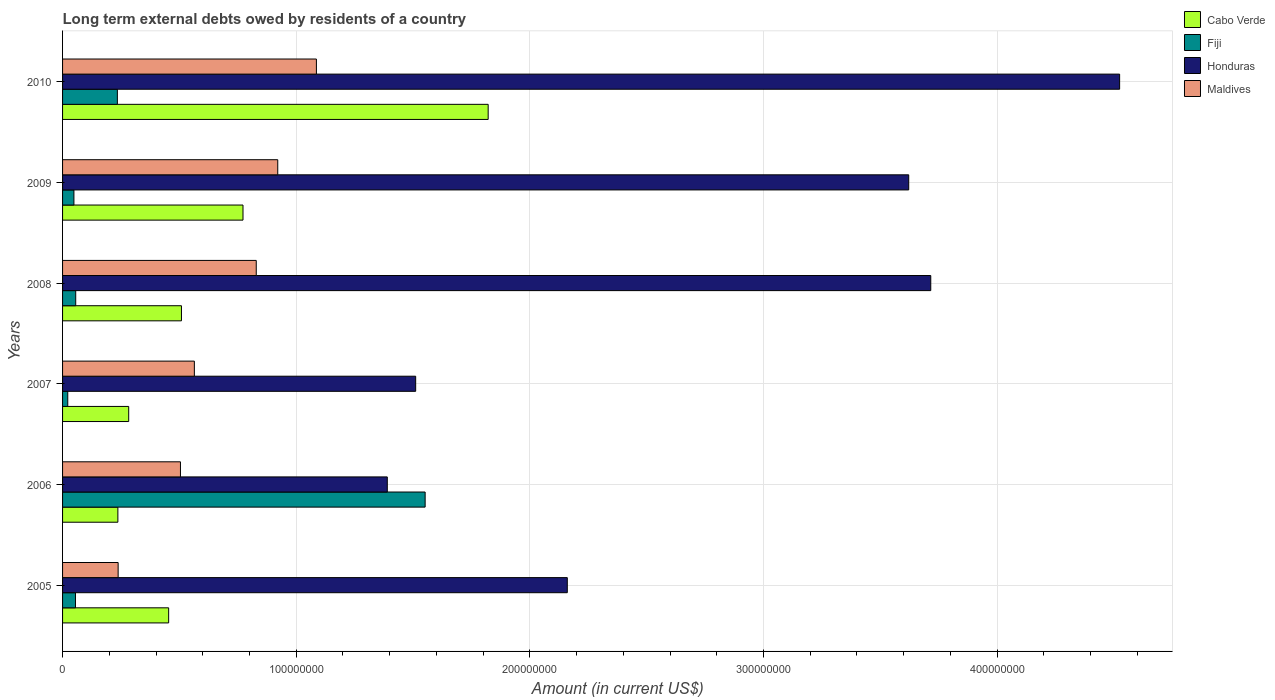How many different coloured bars are there?
Your answer should be compact. 4. Are the number of bars per tick equal to the number of legend labels?
Your answer should be compact. Yes. How many bars are there on the 4th tick from the bottom?
Your answer should be compact. 4. What is the amount of long-term external debts owed by residents in Maldives in 2010?
Provide a succinct answer. 1.09e+08. Across all years, what is the maximum amount of long-term external debts owed by residents in Cabo Verde?
Your response must be concise. 1.82e+08. Across all years, what is the minimum amount of long-term external debts owed by residents in Honduras?
Provide a succinct answer. 1.39e+08. In which year was the amount of long-term external debts owed by residents in Honduras minimum?
Give a very brief answer. 2006. What is the total amount of long-term external debts owed by residents in Fiji in the graph?
Make the answer very short. 1.97e+08. What is the difference between the amount of long-term external debts owed by residents in Honduras in 2006 and that in 2010?
Give a very brief answer. -3.13e+08. What is the difference between the amount of long-term external debts owed by residents in Honduras in 2006 and the amount of long-term external debts owed by residents in Cabo Verde in 2009?
Your answer should be very brief. 6.18e+07. What is the average amount of long-term external debts owed by residents in Fiji per year?
Offer a terse response. 3.28e+07. In the year 2008, what is the difference between the amount of long-term external debts owed by residents in Honduras and amount of long-term external debts owed by residents in Cabo Verde?
Give a very brief answer. 3.21e+08. What is the ratio of the amount of long-term external debts owed by residents in Cabo Verde in 2005 to that in 2007?
Offer a very short reply. 1.6. Is the amount of long-term external debts owed by residents in Fiji in 2008 less than that in 2009?
Make the answer very short. No. What is the difference between the highest and the second highest amount of long-term external debts owed by residents in Cabo Verde?
Ensure brevity in your answer.  1.05e+08. What is the difference between the highest and the lowest amount of long-term external debts owed by residents in Maldives?
Offer a terse response. 8.49e+07. In how many years, is the amount of long-term external debts owed by residents in Fiji greater than the average amount of long-term external debts owed by residents in Fiji taken over all years?
Ensure brevity in your answer.  1. Is it the case that in every year, the sum of the amount of long-term external debts owed by residents in Cabo Verde and amount of long-term external debts owed by residents in Maldives is greater than the sum of amount of long-term external debts owed by residents in Fiji and amount of long-term external debts owed by residents in Honduras?
Your answer should be compact. No. What does the 2nd bar from the top in 2010 represents?
Your response must be concise. Honduras. What does the 2nd bar from the bottom in 2009 represents?
Provide a succinct answer. Fiji. How many bars are there?
Your answer should be very brief. 24. Are all the bars in the graph horizontal?
Your answer should be very brief. Yes. Are the values on the major ticks of X-axis written in scientific E-notation?
Keep it short and to the point. No. Does the graph contain any zero values?
Make the answer very short. No. Where does the legend appear in the graph?
Your answer should be very brief. Top right. How are the legend labels stacked?
Your answer should be compact. Vertical. What is the title of the graph?
Make the answer very short. Long term external debts owed by residents of a country. What is the label or title of the X-axis?
Your response must be concise. Amount (in current US$). What is the label or title of the Y-axis?
Your answer should be very brief. Years. What is the Amount (in current US$) of Cabo Verde in 2005?
Keep it short and to the point. 4.54e+07. What is the Amount (in current US$) in Fiji in 2005?
Offer a terse response. 5.53e+06. What is the Amount (in current US$) of Honduras in 2005?
Give a very brief answer. 2.16e+08. What is the Amount (in current US$) in Maldives in 2005?
Provide a short and direct response. 2.38e+07. What is the Amount (in current US$) in Cabo Verde in 2006?
Give a very brief answer. 2.37e+07. What is the Amount (in current US$) of Fiji in 2006?
Your answer should be very brief. 1.55e+08. What is the Amount (in current US$) in Honduras in 2006?
Ensure brevity in your answer.  1.39e+08. What is the Amount (in current US$) of Maldives in 2006?
Your response must be concise. 5.05e+07. What is the Amount (in current US$) of Cabo Verde in 2007?
Your answer should be very brief. 2.83e+07. What is the Amount (in current US$) of Fiji in 2007?
Your response must be concise. 2.23e+06. What is the Amount (in current US$) of Honduras in 2007?
Your answer should be very brief. 1.51e+08. What is the Amount (in current US$) in Maldives in 2007?
Ensure brevity in your answer.  5.64e+07. What is the Amount (in current US$) in Cabo Verde in 2008?
Ensure brevity in your answer.  5.09e+07. What is the Amount (in current US$) of Fiji in 2008?
Keep it short and to the point. 5.63e+06. What is the Amount (in current US$) in Honduras in 2008?
Your response must be concise. 3.72e+08. What is the Amount (in current US$) of Maldives in 2008?
Ensure brevity in your answer.  8.29e+07. What is the Amount (in current US$) of Cabo Verde in 2009?
Offer a very short reply. 7.72e+07. What is the Amount (in current US$) of Fiji in 2009?
Keep it short and to the point. 4.86e+06. What is the Amount (in current US$) in Honduras in 2009?
Keep it short and to the point. 3.62e+08. What is the Amount (in current US$) of Maldives in 2009?
Your answer should be very brief. 9.21e+07. What is the Amount (in current US$) in Cabo Verde in 2010?
Offer a very short reply. 1.82e+08. What is the Amount (in current US$) of Fiji in 2010?
Your answer should be compact. 2.35e+07. What is the Amount (in current US$) of Honduras in 2010?
Offer a terse response. 4.52e+08. What is the Amount (in current US$) of Maldives in 2010?
Provide a succinct answer. 1.09e+08. Across all years, what is the maximum Amount (in current US$) in Cabo Verde?
Provide a succinct answer. 1.82e+08. Across all years, what is the maximum Amount (in current US$) of Fiji?
Provide a succinct answer. 1.55e+08. Across all years, what is the maximum Amount (in current US$) in Honduras?
Make the answer very short. 4.52e+08. Across all years, what is the maximum Amount (in current US$) in Maldives?
Offer a very short reply. 1.09e+08. Across all years, what is the minimum Amount (in current US$) in Cabo Verde?
Your answer should be very brief. 2.37e+07. Across all years, what is the minimum Amount (in current US$) in Fiji?
Your answer should be compact. 2.23e+06. Across all years, what is the minimum Amount (in current US$) in Honduras?
Provide a short and direct response. 1.39e+08. Across all years, what is the minimum Amount (in current US$) in Maldives?
Your answer should be very brief. 2.38e+07. What is the total Amount (in current US$) of Cabo Verde in the graph?
Your answer should be compact. 4.08e+08. What is the total Amount (in current US$) of Fiji in the graph?
Provide a short and direct response. 1.97e+08. What is the total Amount (in current US$) in Honduras in the graph?
Provide a short and direct response. 1.69e+09. What is the total Amount (in current US$) in Maldives in the graph?
Provide a short and direct response. 4.14e+08. What is the difference between the Amount (in current US$) in Cabo Verde in 2005 and that in 2006?
Provide a short and direct response. 2.17e+07. What is the difference between the Amount (in current US$) in Fiji in 2005 and that in 2006?
Ensure brevity in your answer.  -1.50e+08. What is the difference between the Amount (in current US$) in Honduras in 2005 and that in 2006?
Offer a very short reply. 7.70e+07. What is the difference between the Amount (in current US$) of Maldives in 2005 and that in 2006?
Provide a succinct answer. -2.67e+07. What is the difference between the Amount (in current US$) in Cabo Verde in 2005 and that in 2007?
Keep it short and to the point. 1.71e+07. What is the difference between the Amount (in current US$) of Fiji in 2005 and that in 2007?
Your response must be concise. 3.30e+06. What is the difference between the Amount (in current US$) in Honduras in 2005 and that in 2007?
Give a very brief answer. 6.49e+07. What is the difference between the Amount (in current US$) in Maldives in 2005 and that in 2007?
Keep it short and to the point. -3.26e+07. What is the difference between the Amount (in current US$) in Cabo Verde in 2005 and that in 2008?
Keep it short and to the point. -5.48e+06. What is the difference between the Amount (in current US$) in Fiji in 2005 and that in 2008?
Ensure brevity in your answer.  -1.01e+05. What is the difference between the Amount (in current US$) of Honduras in 2005 and that in 2008?
Provide a succinct answer. -1.56e+08. What is the difference between the Amount (in current US$) in Maldives in 2005 and that in 2008?
Offer a terse response. -5.91e+07. What is the difference between the Amount (in current US$) of Cabo Verde in 2005 and that in 2009?
Make the answer very short. -3.18e+07. What is the difference between the Amount (in current US$) of Fiji in 2005 and that in 2009?
Make the answer very short. 6.65e+05. What is the difference between the Amount (in current US$) in Honduras in 2005 and that in 2009?
Your answer should be compact. -1.46e+08. What is the difference between the Amount (in current US$) of Maldives in 2005 and that in 2009?
Offer a terse response. -6.83e+07. What is the difference between the Amount (in current US$) of Cabo Verde in 2005 and that in 2010?
Offer a very short reply. -1.37e+08. What is the difference between the Amount (in current US$) in Fiji in 2005 and that in 2010?
Offer a very short reply. -1.79e+07. What is the difference between the Amount (in current US$) of Honduras in 2005 and that in 2010?
Give a very brief answer. -2.36e+08. What is the difference between the Amount (in current US$) in Maldives in 2005 and that in 2010?
Offer a very short reply. -8.49e+07. What is the difference between the Amount (in current US$) of Cabo Verde in 2006 and that in 2007?
Your response must be concise. -4.64e+06. What is the difference between the Amount (in current US$) of Fiji in 2006 and that in 2007?
Your response must be concise. 1.53e+08. What is the difference between the Amount (in current US$) in Honduras in 2006 and that in 2007?
Provide a short and direct response. -1.21e+07. What is the difference between the Amount (in current US$) of Maldives in 2006 and that in 2007?
Make the answer very short. -5.95e+06. What is the difference between the Amount (in current US$) of Cabo Verde in 2006 and that in 2008?
Your answer should be compact. -2.72e+07. What is the difference between the Amount (in current US$) in Fiji in 2006 and that in 2008?
Your answer should be very brief. 1.50e+08. What is the difference between the Amount (in current US$) of Honduras in 2006 and that in 2008?
Your response must be concise. -2.33e+08. What is the difference between the Amount (in current US$) in Maldives in 2006 and that in 2008?
Keep it short and to the point. -3.24e+07. What is the difference between the Amount (in current US$) of Cabo Verde in 2006 and that in 2009?
Your answer should be very brief. -5.36e+07. What is the difference between the Amount (in current US$) of Fiji in 2006 and that in 2009?
Your response must be concise. 1.50e+08. What is the difference between the Amount (in current US$) of Honduras in 2006 and that in 2009?
Offer a very short reply. -2.23e+08. What is the difference between the Amount (in current US$) of Maldives in 2006 and that in 2009?
Your response must be concise. -4.16e+07. What is the difference between the Amount (in current US$) of Cabo Verde in 2006 and that in 2010?
Your response must be concise. -1.58e+08. What is the difference between the Amount (in current US$) of Fiji in 2006 and that in 2010?
Your answer should be compact. 1.32e+08. What is the difference between the Amount (in current US$) of Honduras in 2006 and that in 2010?
Make the answer very short. -3.13e+08. What is the difference between the Amount (in current US$) of Maldives in 2006 and that in 2010?
Your answer should be very brief. -5.82e+07. What is the difference between the Amount (in current US$) in Cabo Verde in 2007 and that in 2008?
Your answer should be compact. -2.26e+07. What is the difference between the Amount (in current US$) of Fiji in 2007 and that in 2008?
Offer a terse response. -3.40e+06. What is the difference between the Amount (in current US$) in Honduras in 2007 and that in 2008?
Keep it short and to the point. -2.20e+08. What is the difference between the Amount (in current US$) in Maldives in 2007 and that in 2008?
Make the answer very short. -2.65e+07. What is the difference between the Amount (in current US$) in Cabo Verde in 2007 and that in 2009?
Offer a terse response. -4.89e+07. What is the difference between the Amount (in current US$) in Fiji in 2007 and that in 2009?
Make the answer very short. -2.64e+06. What is the difference between the Amount (in current US$) of Honduras in 2007 and that in 2009?
Ensure brevity in your answer.  -2.11e+08. What is the difference between the Amount (in current US$) of Maldives in 2007 and that in 2009?
Ensure brevity in your answer.  -3.57e+07. What is the difference between the Amount (in current US$) in Cabo Verde in 2007 and that in 2010?
Provide a short and direct response. -1.54e+08. What is the difference between the Amount (in current US$) of Fiji in 2007 and that in 2010?
Offer a terse response. -2.12e+07. What is the difference between the Amount (in current US$) in Honduras in 2007 and that in 2010?
Offer a very short reply. -3.01e+08. What is the difference between the Amount (in current US$) of Maldives in 2007 and that in 2010?
Offer a very short reply. -5.22e+07. What is the difference between the Amount (in current US$) of Cabo Verde in 2008 and that in 2009?
Keep it short and to the point. -2.63e+07. What is the difference between the Amount (in current US$) of Fiji in 2008 and that in 2009?
Give a very brief answer. 7.66e+05. What is the difference between the Amount (in current US$) in Honduras in 2008 and that in 2009?
Your answer should be very brief. 9.44e+06. What is the difference between the Amount (in current US$) in Maldives in 2008 and that in 2009?
Make the answer very short. -9.20e+06. What is the difference between the Amount (in current US$) of Cabo Verde in 2008 and that in 2010?
Provide a short and direct response. -1.31e+08. What is the difference between the Amount (in current US$) of Fiji in 2008 and that in 2010?
Provide a succinct answer. -1.78e+07. What is the difference between the Amount (in current US$) in Honduras in 2008 and that in 2010?
Your answer should be very brief. -8.08e+07. What is the difference between the Amount (in current US$) of Maldives in 2008 and that in 2010?
Your answer should be very brief. -2.57e+07. What is the difference between the Amount (in current US$) in Cabo Verde in 2009 and that in 2010?
Provide a short and direct response. -1.05e+08. What is the difference between the Amount (in current US$) of Fiji in 2009 and that in 2010?
Provide a short and direct response. -1.86e+07. What is the difference between the Amount (in current US$) in Honduras in 2009 and that in 2010?
Provide a short and direct response. -9.03e+07. What is the difference between the Amount (in current US$) in Maldives in 2009 and that in 2010?
Your response must be concise. -1.65e+07. What is the difference between the Amount (in current US$) of Cabo Verde in 2005 and the Amount (in current US$) of Fiji in 2006?
Provide a short and direct response. -1.10e+08. What is the difference between the Amount (in current US$) of Cabo Verde in 2005 and the Amount (in current US$) of Honduras in 2006?
Provide a short and direct response. -9.36e+07. What is the difference between the Amount (in current US$) of Cabo Verde in 2005 and the Amount (in current US$) of Maldives in 2006?
Provide a succinct answer. -5.05e+06. What is the difference between the Amount (in current US$) of Fiji in 2005 and the Amount (in current US$) of Honduras in 2006?
Offer a terse response. -1.33e+08. What is the difference between the Amount (in current US$) in Fiji in 2005 and the Amount (in current US$) in Maldives in 2006?
Keep it short and to the point. -4.49e+07. What is the difference between the Amount (in current US$) in Honduras in 2005 and the Amount (in current US$) in Maldives in 2006?
Your answer should be very brief. 1.66e+08. What is the difference between the Amount (in current US$) of Cabo Verde in 2005 and the Amount (in current US$) of Fiji in 2007?
Your response must be concise. 4.32e+07. What is the difference between the Amount (in current US$) in Cabo Verde in 2005 and the Amount (in current US$) in Honduras in 2007?
Your answer should be compact. -1.06e+08. What is the difference between the Amount (in current US$) in Cabo Verde in 2005 and the Amount (in current US$) in Maldives in 2007?
Ensure brevity in your answer.  -1.10e+07. What is the difference between the Amount (in current US$) of Fiji in 2005 and the Amount (in current US$) of Honduras in 2007?
Ensure brevity in your answer.  -1.46e+08. What is the difference between the Amount (in current US$) in Fiji in 2005 and the Amount (in current US$) in Maldives in 2007?
Your response must be concise. -5.09e+07. What is the difference between the Amount (in current US$) in Honduras in 2005 and the Amount (in current US$) in Maldives in 2007?
Offer a terse response. 1.60e+08. What is the difference between the Amount (in current US$) in Cabo Verde in 2005 and the Amount (in current US$) in Fiji in 2008?
Your response must be concise. 3.98e+07. What is the difference between the Amount (in current US$) in Cabo Verde in 2005 and the Amount (in current US$) in Honduras in 2008?
Make the answer very short. -3.26e+08. What is the difference between the Amount (in current US$) in Cabo Verde in 2005 and the Amount (in current US$) in Maldives in 2008?
Offer a terse response. -3.75e+07. What is the difference between the Amount (in current US$) of Fiji in 2005 and the Amount (in current US$) of Honduras in 2008?
Keep it short and to the point. -3.66e+08. What is the difference between the Amount (in current US$) of Fiji in 2005 and the Amount (in current US$) of Maldives in 2008?
Offer a terse response. -7.74e+07. What is the difference between the Amount (in current US$) of Honduras in 2005 and the Amount (in current US$) of Maldives in 2008?
Provide a short and direct response. 1.33e+08. What is the difference between the Amount (in current US$) of Cabo Verde in 2005 and the Amount (in current US$) of Fiji in 2009?
Your response must be concise. 4.05e+07. What is the difference between the Amount (in current US$) of Cabo Verde in 2005 and the Amount (in current US$) of Honduras in 2009?
Keep it short and to the point. -3.17e+08. What is the difference between the Amount (in current US$) of Cabo Verde in 2005 and the Amount (in current US$) of Maldives in 2009?
Provide a short and direct response. -4.67e+07. What is the difference between the Amount (in current US$) in Fiji in 2005 and the Amount (in current US$) in Honduras in 2009?
Keep it short and to the point. -3.57e+08. What is the difference between the Amount (in current US$) of Fiji in 2005 and the Amount (in current US$) of Maldives in 2009?
Ensure brevity in your answer.  -8.66e+07. What is the difference between the Amount (in current US$) in Honduras in 2005 and the Amount (in current US$) in Maldives in 2009?
Ensure brevity in your answer.  1.24e+08. What is the difference between the Amount (in current US$) of Cabo Verde in 2005 and the Amount (in current US$) of Fiji in 2010?
Your response must be concise. 2.19e+07. What is the difference between the Amount (in current US$) of Cabo Verde in 2005 and the Amount (in current US$) of Honduras in 2010?
Your response must be concise. -4.07e+08. What is the difference between the Amount (in current US$) of Cabo Verde in 2005 and the Amount (in current US$) of Maldives in 2010?
Give a very brief answer. -6.32e+07. What is the difference between the Amount (in current US$) of Fiji in 2005 and the Amount (in current US$) of Honduras in 2010?
Give a very brief answer. -4.47e+08. What is the difference between the Amount (in current US$) in Fiji in 2005 and the Amount (in current US$) in Maldives in 2010?
Offer a very short reply. -1.03e+08. What is the difference between the Amount (in current US$) in Honduras in 2005 and the Amount (in current US$) in Maldives in 2010?
Provide a succinct answer. 1.07e+08. What is the difference between the Amount (in current US$) of Cabo Verde in 2006 and the Amount (in current US$) of Fiji in 2007?
Provide a succinct answer. 2.14e+07. What is the difference between the Amount (in current US$) of Cabo Verde in 2006 and the Amount (in current US$) of Honduras in 2007?
Offer a terse response. -1.27e+08. What is the difference between the Amount (in current US$) in Cabo Verde in 2006 and the Amount (in current US$) in Maldives in 2007?
Ensure brevity in your answer.  -3.27e+07. What is the difference between the Amount (in current US$) in Fiji in 2006 and the Amount (in current US$) in Honduras in 2007?
Offer a terse response. 4.05e+06. What is the difference between the Amount (in current US$) in Fiji in 2006 and the Amount (in current US$) in Maldives in 2007?
Make the answer very short. 9.88e+07. What is the difference between the Amount (in current US$) of Honduras in 2006 and the Amount (in current US$) of Maldives in 2007?
Your answer should be very brief. 8.26e+07. What is the difference between the Amount (in current US$) of Cabo Verde in 2006 and the Amount (in current US$) of Fiji in 2008?
Offer a very short reply. 1.80e+07. What is the difference between the Amount (in current US$) in Cabo Verde in 2006 and the Amount (in current US$) in Honduras in 2008?
Your response must be concise. -3.48e+08. What is the difference between the Amount (in current US$) in Cabo Verde in 2006 and the Amount (in current US$) in Maldives in 2008?
Ensure brevity in your answer.  -5.92e+07. What is the difference between the Amount (in current US$) in Fiji in 2006 and the Amount (in current US$) in Honduras in 2008?
Your answer should be very brief. -2.16e+08. What is the difference between the Amount (in current US$) in Fiji in 2006 and the Amount (in current US$) in Maldives in 2008?
Your response must be concise. 7.23e+07. What is the difference between the Amount (in current US$) of Honduras in 2006 and the Amount (in current US$) of Maldives in 2008?
Your response must be concise. 5.61e+07. What is the difference between the Amount (in current US$) in Cabo Verde in 2006 and the Amount (in current US$) in Fiji in 2009?
Offer a terse response. 1.88e+07. What is the difference between the Amount (in current US$) of Cabo Verde in 2006 and the Amount (in current US$) of Honduras in 2009?
Your answer should be compact. -3.38e+08. What is the difference between the Amount (in current US$) of Cabo Verde in 2006 and the Amount (in current US$) of Maldives in 2009?
Make the answer very short. -6.84e+07. What is the difference between the Amount (in current US$) of Fiji in 2006 and the Amount (in current US$) of Honduras in 2009?
Your answer should be compact. -2.07e+08. What is the difference between the Amount (in current US$) in Fiji in 2006 and the Amount (in current US$) in Maldives in 2009?
Offer a very short reply. 6.31e+07. What is the difference between the Amount (in current US$) in Honduras in 2006 and the Amount (in current US$) in Maldives in 2009?
Provide a short and direct response. 4.69e+07. What is the difference between the Amount (in current US$) of Cabo Verde in 2006 and the Amount (in current US$) of Fiji in 2010?
Your response must be concise. 2.11e+05. What is the difference between the Amount (in current US$) of Cabo Verde in 2006 and the Amount (in current US$) of Honduras in 2010?
Offer a terse response. -4.29e+08. What is the difference between the Amount (in current US$) of Cabo Verde in 2006 and the Amount (in current US$) of Maldives in 2010?
Your answer should be very brief. -8.50e+07. What is the difference between the Amount (in current US$) in Fiji in 2006 and the Amount (in current US$) in Honduras in 2010?
Your answer should be very brief. -2.97e+08. What is the difference between the Amount (in current US$) in Fiji in 2006 and the Amount (in current US$) in Maldives in 2010?
Provide a short and direct response. 4.65e+07. What is the difference between the Amount (in current US$) in Honduras in 2006 and the Amount (in current US$) in Maldives in 2010?
Make the answer very short. 3.03e+07. What is the difference between the Amount (in current US$) of Cabo Verde in 2007 and the Amount (in current US$) of Fiji in 2008?
Make the answer very short. 2.27e+07. What is the difference between the Amount (in current US$) of Cabo Verde in 2007 and the Amount (in current US$) of Honduras in 2008?
Offer a terse response. -3.43e+08. What is the difference between the Amount (in current US$) in Cabo Verde in 2007 and the Amount (in current US$) in Maldives in 2008?
Provide a short and direct response. -5.46e+07. What is the difference between the Amount (in current US$) of Fiji in 2007 and the Amount (in current US$) of Honduras in 2008?
Provide a short and direct response. -3.69e+08. What is the difference between the Amount (in current US$) in Fiji in 2007 and the Amount (in current US$) in Maldives in 2008?
Offer a very short reply. -8.07e+07. What is the difference between the Amount (in current US$) in Honduras in 2007 and the Amount (in current US$) in Maldives in 2008?
Your response must be concise. 6.82e+07. What is the difference between the Amount (in current US$) of Cabo Verde in 2007 and the Amount (in current US$) of Fiji in 2009?
Your response must be concise. 2.34e+07. What is the difference between the Amount (in current US$) in Cabo Verde in 2007 and the Amount (in current US$) in Honduras in 2009?
Your answer should be very brief. -3.34e+08. What is the difference between the Amount (in current US$) in Cabo Verde in 2007 and the Amount (in current US$) in Maldives in 2009?
Provide a succinct answer. -6.38e+07. What is the difference between the Amount (in current US$) in Fiji in 2007 and the Amount (in current US$) in Honduras in 2009?
Ensure brevity in your answer.  -3.60e+08. What is the difference between the Amount (in current US$) of Fiji in 2007 and the Amount (in current US$) of Maldives in 2009?
Give a very brief answer. -8.99e+07. What is the difference between the Amount (in current US$) in Honduras in 2007 and the Amount (in current US$) in Maldives in 2009?
Make the answer very short. 5.90e+07. What is the difference between the Amount (in current US$) in Cabo Verde in 2007 and the Amount (in current US$) in Fiji in 2010?
Give a very brief answer. 4.85e+06. What is the difference between the Amount (in current US$) of Cabo Verde in 2007 and the Amount (in current US$) of Honduras in 2010?
Your answer should be very brief. -4.24e+08. What is the difference between the Amount (in current US$) of Cabo Verde in 2007 and the Amount (in current US$) of Maldives in 2010?
Provide a succinct answer. -8.03e+07. What is the difference between the Amount (in current US$) in Fiji in 2007 and the Amount (in current US$) in Honduras in 2010?
Your response must be concise. -4.50e+08. What is the difference between the Amount (in current US$) in Fiji in 2007 and the Amount (in current US$) in Maldives in 2010?
Offer a very short reply. -1.06e+08. What is the difference between the Amount (in current US$) of Honduras in 2007 and the Amount (in current US$) of Maldives in 2010?
Your response must be concise. 4.25e+07. What is the difference between the Amount (in current US$) of Cabo Verde in 2008 and the Amount (in current US$) of Fiji in 2009?
Your answer should be very brief. 4.60e+07. What is the difference between the Amount (in current US$) in Cabo Verde in 2008 and the Amount (in current US$) in Honduras in 2009?
Give a very brief answer. -3.11e+08. What is the difference between the Amount (in current US$) in Cabo Verde in 2008 and the Amount (in current US$) in Maldives in 2009?
Ensure brevity in your answer.  -4.12e+07. What is the difference between the Amount (in current US$) of Fiji in 2008 and the Amount (in current US$) of Honduras in 2009?
Ensure brevity in your answer.  -3.57e+08. What is the difference between the Amount (in current US$) in Fiji in 2008 and the Amount (in current US$) in Maldives in 2009?
Your response must be concise. -8.65e+07. What is the difference between the Amount (in current US$) in Honduras in 2008 and the Amount (in current US$) in Maldives in 2009?
Your response must be concise. 2.80e+08. What is the difference between the Amount (in current US$) of Cabo Verde in 2008 and the Amount (in current US$) of Fiji in 2010?
Provide a succinct answer. 2.74e+07. What is the difference between the Amount (in current US$) in Cabo Verde in 2008 and the Amount (in current US$) in Honduras in 2010?
Your response must be concise. -4.02e+08. What is the difference between the Amount (in current US$) of Cabo Verde in 2008 and the Amount (in current US$) of Maldives in 2010?
Your answer should be very brief. -5.78e+07. What is the difference between the Amount (in current US$) of Fiji in 2008 and the Amount (in current US$) of Honduras in 2010?
Offer a very short reply. -4.47e+08. What is the difference between the Amount (in current US$) in Fiji in 2008 and the Amount (in current US$) in Maldives in 2010?
Your response must be concise. -1.03e+08. What is the difference between the Amount (in current US$) of Honduras in 2008 and the Amount (in current US$) of Maldives in 2010?
Provide a short and direct response. 2.63e+08. What is the difference between the Amount (in current US$) of Cabo Verde in 2009 and the Amount (in current US$) of Fiji in 2010?
Provide a succinct answer. 5.38e+07. What is the difference between the Amount (in current US$) of Cabo Verde in 2009 and the Amount (in current US$) of Honduras in 2010?
Ensure brevity in your answer.  -3.75e+08. What is the difference between the Amount (in current US$) of Cabo Verde in 2009 and the Amount (in current US$) of Maldives in 2010?
Offer a terse response. -3.14e+07. What is the difference between the Amount (in current US$) in Fiji in 2009 and the Amount (in current US$) in Honduras in 2010?
Provide a succinct answer. -4.48e+08. What is the difference between the Amount (in current US$) in Fiji in 2009 and the Amount (in current US$) in Maldives in 2010?
Provide a short and direct response. -1.04e+08. What is the difference between the Amount (in current US$) of Honduras in 2009 and the Amount (in current US$) of Maldives in 2010?
Provide a short and direct response. 2.54e+08. What is the average Amount (in current US$) in Cabo Verde per year?
Make the answer very short. 6.79e+07. What is the average Amount (in current US$) of Fiji per year?
Ensure brevity in your answer.  3.28e+07. What is the average Amount (in current US$) of Honduras per year?
Offer a very short reply. 2.82e+08. What is the average Amount (in current US$) of Maldives per year?
Your response must be concise. 6.91e+07. In the year 2005, what is the difference between the Amount (in current US$) of Cabo Verde and Amount (in current US$) of Fiji?
Your answer should be compact. 3.99e+07. In the year 2005, what is the difference between the Amount (in current US$) of Cabo Verde and Amount (in current US$) of Honduras?
Provide a succinct answer. -1.71e+08. In the year 2005, what is the difference between the Amount (in current US$) of Cabo Verde and Amount (in current US$) of Maldives?
Offer a terse response. 2.16e+07. In the year 2005, what is the difference between the Amount (in current US$) of Fiji and Amount (in current US$) of Honduras?
Your answer should be very brief. -2.11e+08. In the year 2005, what is the difference between the Amount (in current US$) of Fiji and Amount (in current US$) of Maldives?
Offer a very short reply. -1.83e+07. In the year 2005, what is the difference between the Amount (in current US$) of Honduras and Amount (in current US$) of Maldives?
Offer a very short reply. 1.92e+08. In the year 2006, what is the difference between the Amount (in current US$) in Cabo Verde and Amount (in current US$) in Fiji?
Your response must be concise. -1.32e+08. In the year 2006, what is the difference between the Amount (in current US$) of Cabo Verde and Amount (in current US$) of Honduras?
Your answer should be very brief. -1.15e+08. In the year 2006, what is the difference between the Amount (in current US$) of Cabo Verde and Amount (in current US$) of Maldives?
Provide a short and direct response. -2.68e+07. In the year 2006, what is the difference between the Amount (in current US$) of Fiji and Amount (in current US$) of Honduras?
Offer a terse response. 1.62e+07. In the year 2006, what is the difference between the Amount (in current US$) of Fiji and Amount (in current US$) of Maldives?
Ensure brevity in your answer.  1.05e+08. In the year 2006, what is the difference between the Amount (in current US$) of Honduras and Amount (in current US$) of Maldives?
Your answer should be very brief. 8.85e+07. In the year 2007, what is the difference between the Amount (in current US$) in Cabo Verde and Amount (in current US$) in Fiji?
Provide a succinct answer. 2.61e+07. In the year 2007, what is the difference between the Amount (in current US$) in Cabo Verde and Amount (in current US$) in Honduras?
Provide a succinct answer. -1.23e+08. In the year 2007, what is the difference between the Amount (in current US$) of Cabo Verde and Amount (in current US$) of Maldives?
Offer a very short reply. -2.81e+07. In the year 2007, what is the difference between the Amount (in current US$) of Fiji and Amount (in current US$) of Honduras?
Your response must be concise. -1.49e+08. In the year 2007, what is the difference between the Amount (in current US$) of Fiji and Amount (in current US$) of Maldives?
Give a very brief answer. -5.42e+07. In the year 2007, what is the difference between the Amount (in current US$) of Honduras and Amount (in current US$) of Maldives?
Provide a short and direct response. 9.47e+07. In the year 2008, what is the difference between the Amount (in current US$) of Cabo Verde and Amount (in current US$) of Fiji?
Your answer should be very brief. 4.53e+07. In the year 2008, what is the difference between the Amount (in current US$) of Cabo Verde and Amount (in current US$) of Honduras?
Offer a terse response. -3.21e+08. In the year 2008, what is the difference between the Amount (in current US$) in Cabo Verde and Amount (in current US$) in Maldives?
Your response must be concise. -3.20e+07. In the year 2008, what is the difference between the Amount (in current US$) in Fiji and Amount (in current US$) in Honduras?
Keep it short and to the point. -3.66e+08. In the year 2008, what is the difference between the Amount (in current US$) in Fiji and Amount (in current US$) in Maldives?
Ensure brevity in your answer.  -7.73e+07. In the year 2008, what is the difference between the Amount (in current US$) of Honduras and Amount (in current US$) of Maldives?
Provide a short and direct response. 2.89e+08. In the year 2009, what is the difference between the Amount (in current US$) of Cabo Verde and Amount (in current US$) of Fiji?
Offer a very short reply. 7.24e+07. In the year 2009, what is the difference between the Amount (in current US$) of Cabo Verde and Amount (in current US$) of Honduras?
Keep it short and to the point. -2.85e+08. In the year 2009, what is the difference between the Amount (in current US$) of Cabo Verde and Amount (in current US$) of Maldives?
Offer a terse response. -1.49e+07. In the year 2009, what is the difference between the Amount (in current US$) of Fiji and Amount (in current US$) of Honduras?
Provide a succinct answer. -3.57e+08. In the year 2009, what is the difference between the Amount (in current US$) of Fiji and Amount (in current US$) of Maldives?
Keep it short and to the point. -8.72e+07. In the year 2009, what is the difference between the Amount (in current US$) in Honduras and Amount (in current US$) in Maldives?
Provide a short and direct response. 2.70e+08. In the year 2010, what is the difference between the Amount (in current US$) of Cabo Verde and Amount (in current US$) of Fiji?
Offer a terse response. 1.59e+08. In the year 2010, what is the difference between the Amount (in current US$) of Cabo Verde and Amount (in current US$) of Honduras?
Give a very brief answer. -2.70e+08. In the year 2010, what is the difference between the Amount (in current US$) of Cabo Verde and Amount (in current US$) of Maldives?
Make the answer very short. 7.35e+07. In the year 2010, what is the difference between the Amount (in current US$) of Fiji and Amount (in current US$) of Honduras?
Your answer should be very brief. -4.29e+08. In the year 2010, what is the difference between the Amount (in current US$) of Fiji and Amount (in current US$) of Maldives?
Keep it short and to the point. -8.52e+07. In the year 2010, what is the difference between the Amount (in current US$) of Honduras and Amount (in current US$) of Maldives?
Your response must be concise. 3.44e+08. What is the ratio of the Amount (in current US$) of Cabo Verde in 2005 to that in 2006?
Your answer should be very brief. 1.92. What is the ratio of the Amount (in current US$) in Fiji in 2005 to that in 2006?
Offer a very short reply. 0.04. What is the ratio of the Amount (in current US$) in Honduras in 2005 to that in 2006?
Make the answer very short. 1.55. What is the ratio of the Amount (in current US$) of Maldives in 2005 to that in 2006?
Keep it short and to the point. 0.47. What is the ratio of the Amount (in current US$) in Cabo Verde in 2005 to that in 2007?
Offer a terse response. 1.6. What is the ratio of the Amount (in current US$) in Fiji in 2005 to that in 2007?
Make the answer very short. 2.48. What is the ratio of the Amount (in current US$) of Honduras in 2005 to that in 2007?
Provide a succinct answer. 1.43. What is the ratio of the Amount (in current US$) of Maldives in 2005 to that in 2007?
Give a very brief answer. 0.42. What is the ratio of the Amount (in current US$) of Cabo Verde in 2005 to that in 2008?
Provide a short and direct response. 0.89. What is the ratio of the Amount (in current US$) in Fiji in 2005 to that in 2008?
Your answer should be very brief. 0.98. What is the ratio of the Amount (in current US$) in Honduras in 2005 to that in 2008?
Your answer should be compact. 0.58. What is the ratio of the Amount (in current US$) of Maldives in 2005 to that in 2008?
Make the answer very short. 0.29. What is the ratio of the Amount (in current US$) in Cabo Verde in 2005 to that in 2009?
Provide a succinct answer. 0.59. What is the ratio of the Amount (in current US$) of Fiji in 2005 to that in 2009?
Give a very brief answer. 1.14. What is the ratio of the Amount (in current US$) of Honduras in 2005 to that in 2009?
Offer a terse response. 0.6. What is the ratio of the Amount (in current US$) in Maldives in 2005 to that in 2009?
Give a very brief answer. 0.26. What is the ratio of the Amount (in current US$) in Cabo Verde in 2005 to that in 2010?
Offer a very short reply. 0.25. What is the ratio of the Amount (in current US$) of Fiji in 2005 to that in 2010?
Provide a short and direct response. 0.24. What is the ratio of the Amount (in current US$) of Honduras in 2005 to that in 2010?
Your answer should be compact. 0.48. What is the ratio of the Amount (in current US$) of Maldives in 2005 to that in 2010?
Your answer should be very brief. 0.22. What is the ratio of the Amount (in current US$) of Cabo Verde in 2006 to that in 2007?
Give a very brief answer. 0.84. What is the ratio of the Amount (in current US$) of Fiji in 2006 to that in 2007?
Provide a short and direct response. 69.72. What is the ratio of the Amount (in current US$) of Honduras in 2006 to that in 2007?
Make the answer very short. 0.92. What is the ratio of the Amount (in current US$) of Maldives in 2006 to that in 2007?
Provide a succinct answer. 0.89. What is the ratio of the Amount (in current US$) in Cabo Verde in 2006 to that in 2008?
Your answer should be very brief. 0.47. What is the ratio of the Amount (in current US$) in Fiji in 2006 to that in 2008?
Your response must be concise. 27.58. What is the ratio of the Amount (in current US$) of Honduras in 2006 to that in 2008?
Your response must be concise. 0.37. What is the ratio of the Amount (in current US$) of Maldives in 2006 to that in 2008?
Give a very brief answer. 0.61. What is the ratio of the Amount (in current US$) of Cabo Verde in 2006 to that in 2009?
Provide a succinct answer. 0.31. What is the ratio of the Amount (in current US$) of Fiji in 2006 to that in 2009?
Your response must be concise. 31.93. What is the ratio of the Amount (in current US$) in Honduras in 2006 to that in 2009?
Make the answer very short. 0.38. What is the ratio of the Amount (in current US$) in Maldives in 2006 to that in 2009?
Provide a short and direct response. 0.55. What is the ratio of the Amount (in current US$) of Cabo Verde in 2006 to that in 2010?
Your response must be concise. 0.13. What is the ratio of the Amount (in current US$) in Fiji in 2006 to that in 2010?
Give a very brief answer. 6.61. What is the ratio of the Amount (in current US$) of Honduras in 2006 to that in 2010?
Keep it short and to the point. 0.31. What is the ratio of the Amount (in current US$) of Maldives in 2006 to that in 2010?
Ensure brevity in your answer.  0.46. What is the ratio of the Amount (in current US$) of Cabo Verde in 2007 to that in 2008?
Your response must be concise. 0.56. What is the ratio of the Amount (in current US$) of Fiji in 2007 to that in 2008?
Your answer should be very brief. 0.4. What is the ratio of the Amount (in current US$) of Honduras in 2007 to that in 2008?
Offer a terse response. 0.41. What is the ratio of the Amount (in current US$) of Maldives in 2007 to that in 2008?
Your answer should be very brief. 0.68. What is the ratio of the Amount (in current US$) in Cabo Verde in 2007 to that in 2009?
Provide a short and direct response. 0.37. What is the ratio of the Amount (in current US$) of Fiji in 2007 to that in 2009?
Keep it short and to the point. 0.46. What is the ratio of the Amount (in current US$) of Honduras in 2007 to that in 2009?
Offer a terse response. 0.42. What is the ratio of the Amount (in current US$) of Maldives in 2007 to that in 2009?
Offer a very short reply. 0.61. What is the ratio of the Amount (in current US$) in Cabo Verde in 2007 to that in 2010?
Offer a terse response. 0.16. What is the ratio of the Amount (in current US$) in Fiji in 2007 to that in 2010?
Offer a terse response. 0.09. What is the ratio of the Amount (in current US$) of Honduras in 2007 to that in 2010?
Your response must be concise. 0.33. What is the ratio of the Amount (in current US$) of Maldives in 2007 to that in 2010?
Provide a short and direct response. 0.52. What is the ratio of the Amount (in current US$) of Cabo Verde in 2008 to that in 2009?
Give a very brief answer. 0.66. What is the ratio of the Amount (in current US$) in Fiji in 2008 to that in 2009?
Offer a very short reply. 1.16. What is the ratio of the Amount (in current US$) of Honduras in 2008 to that in 2009?
Ensure brevity in your answer.  1.03. What is the ratio of the Amount (in current US$) of Maldives in 2008 to that in 2009?
Ensure brevity in your answer.  0.9. What is the ratio of the Amount (in current US$) of Cabo Verde in 2008 to that in 2010?
Provide a succinct answer. 0.28. What is the ratio of the Amount (in current US$) of Fiji in 2008 to that in 2010?
Your response must be concise. 0.24. What is the ratio of the Amount (in current US$) in Honduras in 2008 to that in 2010?
Offer a very short reply. 0.82. What is the ratio of the Amount (in current US$) of Maldives in 2008 to that in 2010?
Ensure brevity in your answer.  0.76. What is the ratio of the Amount (in current US$) of Cabo Verde in 2009 to that in 2010?
Offer a very short reply. 0.42. What is the ratio of the Amount (in current US$) in Fiji in 2009 to that in 2010?
Offer a terse response. 0.21. What is the ratio of the Amount (in current US$) of Honduras in 2009 to that in 2010?
Your response must be concise. 0.8. What is the ratio of the Amount (in current US$) in Maldives in 2009 to that in 2010?
Your answer should be very brief. 0.85. What is the difference between the highest and the second highest Amount (in current US$) in Cabo Verde?
Give a very brief answer. 1.05e+08. What is the difference between the highest and the second highest Amount (in current US$) in Fiji?
Your response must be concise. 1.32e+08. What is the difference between the highest and the second highest Amount (in current US$) in Honduras?
Your answer should be compact. 8.08e+07. What is the difference between the highest and the second highest Amount (in current US$) in Maldives?
Your answer should be compact. 1.65e+07. What is the difference between the highest and the lowest Amount (in current US$) in Cabo Verde?
Keep it short and to the point. 1.58e+08. What is the difference between the highest and the lowest Amount (in current US$) of Fiji?
Provide a succinct answer. 1.53e+08. What is the difference between the highest and the lowest Amount (in current US$) of Honduras?
Keep it short and to the point. 3.13e+08. What is the difference between the highest and the lowest Amount (in current US$) of Maldives?
Ensure brevity in your answer.  8.49e+07. 